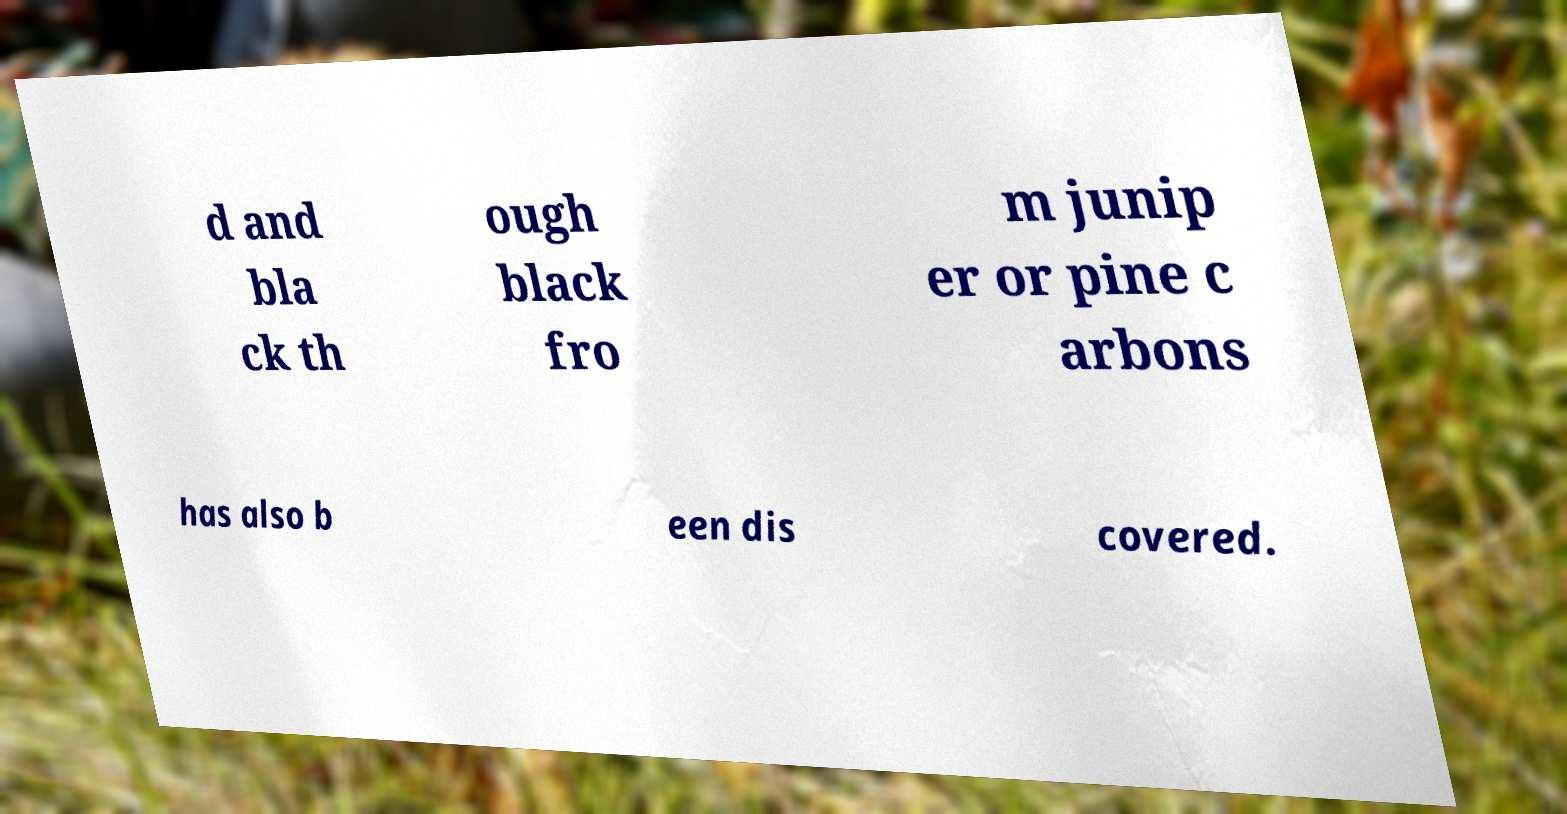There's text embedded in this image that I need extracted. Can you transcribe it verbatim? d and bla ck th ough black fro m junip er or pine c arbons has also b een dis covered. 